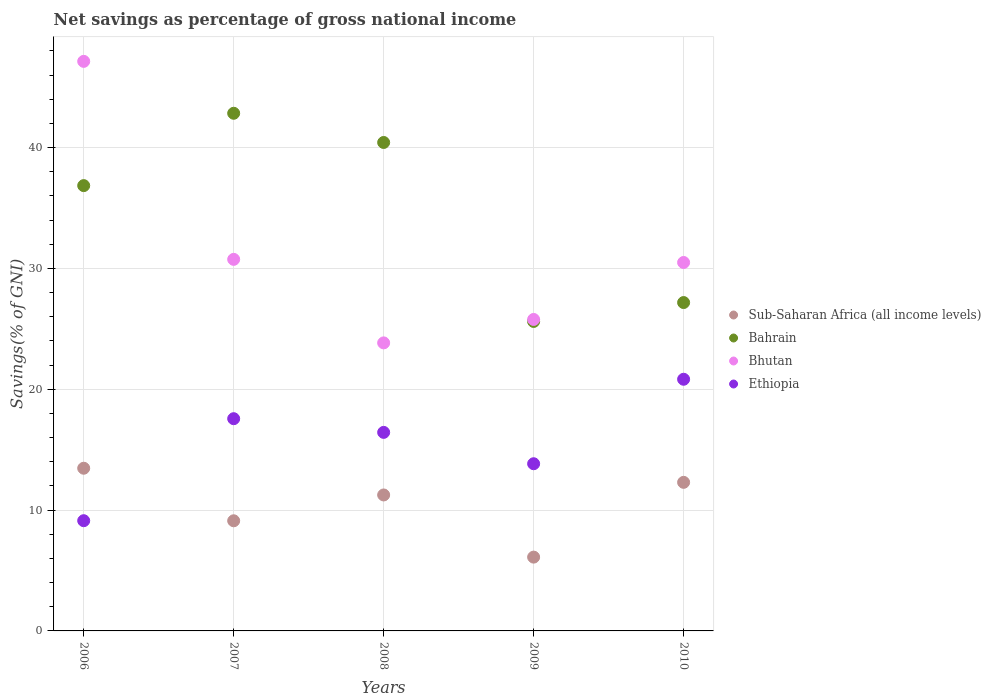How many different coloured dotlines are there?
Offer a terse response. 4. What is the total savings in Ethiopia in 2010?
Ensure brevity in your answer.  20.83. Across all years, what is the maximum total savings in Ethiopia?
Offer a terse response. 20.83. Across all years, what is the minimum total savings in Sub-Saharan Africa (all income levels)?
Give a very brief answer. 6.11. In which year was the total savings in Ethiopia maximum?
Keep it short and to the point. 2010. What is the total total savings in Bhutan in the graph?
Your response must be concise. 157.98. What is the difference between the total savings in Bahrain in 2006 and that in 2007?
Offer a very short reply. -5.99. What is the difference between the total savings in Bhutan in 2006 and the total savings in Ethiopia in 2008?
Keep it short and to the point. 30.7. What is the average total savings in Sub-Saharan Africa (all income levels) per year?
Give a very brief answer. 10.45. In the year 2008, what is the difference between the total savings in Bhutan and total savings in Ethiopia?
Your response must be concise. 7.41. In how many years, is the total savings in Ethiopia greater than 10 %?
Provide a succinct answer. 4. What is the ratio of the total savings in Sub-Saharan Africa (all income levels) in 2006 to that in 2008?
Give a very brief answer. 1.2. Is the total savings in Sub-Saharan Africa (all income levels) in 2009 less than that in 2010?
Provide a succinct answer. Yes. What is the difference between the highest and the second highest total savings in Bhutan?
Your answer should be compact. 16.39. What is the difference between the highest and the lowest total savings in Bhutan?
Your answer should be compact. 23.3. Is the sum of the total savings in Ethiopia in 2009 and 2010 greater than the maximum total savings in Sub-Saharan Africa (all income levels) across all years?
Offer a terse response. Yes. Is it the case that in every year, the sum of the total savings in Ethiopia and total savings in Bhutan  is greater than the sum of total savings in Sub-Saharan Africa (all income levels) and total savings in Bahrain?
Ensure brevity in your answer.  Yes. Is the total savings in Bhutan strictly less than the total savings in Bahrain over the years?
Keep it short and to the point. No. How many dotlines are there?
Provide a short and direct response. 4. How many years are there in the graph?
Offer a terse response. 5. What is the difference between two consecutive major ticks on the Y-axis?
Make the answer very short. 10. Are the values on the major ticks of Y-axis written in scientific E-notation?
Your answer should be very brief. No. What is the title of the graph?
Provide a succinct answer. Net savings as percentage of gross national income. What is the label or title of the X-axis?
Offer a terse response. Years. What is the label or title of the Y-axis?
Make the answer very short. Savings(% of GNI). What is the Savings(% of GNI) of Sub-Saharan Africa (all income levels) in 2006?
Your answer should be very brief. 13.46. What is the Savings(% of GNI) of Bahrain in 2006?
Your answer should be compact. 36.85. What is the Savings(% of GNI) in Bhutan in 2006?
Offer a very short reply. 47.13. What is the Savings(% of GNI) in Ethiopia in 2006?
Give a very brief answer. 9.12. What is the Savings(% of GNI) of Sub-Saharan Africa (all income levels) in 2007?
Ensure brevity in your answer.  9.11. What is the Savings(% of GNI) of Bahrain in 2007?
Your answer should be very brief. 42.84. What is the Savings(% of GNI) in Bhutan in 2007?
Ensure brevity in your answer.  30.75. What is the Savings(% of GNI) in Ethiopia in 2007?
Provide a succinct answer. 17.56. What is the Savings(% of GNI) in Sub-Saharan Africa (all income levels) in 2008?
Offer a very short reply. 11.25. What is the Savings(% of GNI) in Bahrain in 2008?
Keep it short and to the point. 40.42. What is the Savings(% of GNI) of Bhutan in 2008?
Provide a short and direct response. 23.84. What is the Savings(% of GNI) of Ethiopia in 2008?
Offer a very short reply. 16.43. What is the Savings(% of GNI) of Sub-Saharan Africa (all income levels) in 2009?
Your response must be concise. 6.11. What is the Savings(% of GNI) in Bahrain in 2009?
Your response must be concise. 25.61. What is the Savings(% of GNI) of Bhutan in 2009?
Provide a succinct answer. 25.78. What is the Savings(% of GNI) in Ethiopia in 2009?
Provide a succinct answer. 13.84. What is the Savings(% of GNI) in Sub-Saharan Africa (all income levels) in 2010?
Your answer should be compact. 12.3. What is the Savings(% of GNI) in Bahrain in 2010?
Give a very brief answer. 27.17. What is the Savings(% of GNI) in Bhutan in 2010?
Provide a succinct answer. 30.49. What is the Savings(% of GNI) of Ethiopia in 2010?
Give a very brief answer. 20.83. Across all years, what is the maximum Savings(% of GNI) in Sub-Saharan Africa (all income levels)?
Provide a succinct answer. 13.46. Across all years, what is the maximum Savings(% of GNI) of Bahrain?
Make the answer very short. 42.84. Across all years, what is the maximum Savings(% of GNI) in Bhutan?
Give a very brief answer. 47.13. Across all years, what is the maximum Savings(% of GNI) in Ethiopia?
Make the answer very short. 20.83. Across all years, what is the minimum Savings(% of GNI) of Sub-Saharan Africa (all income levels)?
Offer a very short reply. 6.11. Across all years, what is the minimum Savings(% of GNI) of Bahrain?
Your answer should be compact. 25.61. Across all years, what is the minimum Savings(% of GNI) of Bhutan?
Your response must be concise. 23.84. Across all years, what is the minimum Savings(% of GNI) in Ethiopia?
Your answer should be compact. 9.12. What is the total Savings(% of GNI) of Sub-Saharan Africa (all income levels) in the graph?
Keep it short and to the point. 52.23. What is the total Savings(% of GNI) in Bahrain in the graph?
Make the answer very short. 172.89. What is the total Savings(% of GNI) of Bhutan in the graph?
Give a very brief answer. 157.98. What is the total Savings(% of GNI) of Ethiopia in the graph?
Offer a terse response. 77.78. What is the difference between the Savings(% of GNI) of Sub-Saharan Africa (all income levels) in 2006 and that in 2007?
Your answer should be compact. 4.35. What is the difference between the Savings(% of GNI) of Bahrain in 2006 and that in 2007?
Your answer should be compact. -5.99. What is the difference between the Savings(% of GNI) in Bhutan in 2006 and that in 2007?
Your response must be concise. 16.39. What is the difference between the Savings(% of GNI) in Ethiopia in 2006 and that in 2007?
Give a very brief answer. -8.44. What is the difference between the Savings(% of GNI) in Sub-Saharan Africa (all income levels) in 2006 and that in 2008?
Your answer should be compact. 2.21. What is the difference between the Savings(% of GNI) of Bahrain in 2006 and that in 2008?
Your response must be concise. -3.57. What is the difference between the Savings(% of GNI) of Bhutan in 2006 and that in 2008?
Keep it short and to the point. 23.3. What is the difference between the Savings(% of GNI) of Ethiopia in 2006 and that in 2008?
Your answer should be very brief. -7.31. What is the difference between the Savings(% of GNI) in Sub-Saharan Africa (all income levels) in 2006 and that in 2009?
Your answer should be very brief. 7.36. What is the difference between the Savings(% of GNI) of Bahrain in 2006 and that in 2009?
Make the answer very short. 11.24. What is the difference between the Savings(% of GNI) of Bhutan in 2006 and that in 2009?
Offer a very short reply. 21.36. What is the difference between the Savings(% of GNI) of Ethiopia in 2006 and that in 2009?
Ensure brevity in your answer.  -4.71. What is the difference between the Savings(% of GNI) in Sub-Saharan Africa (all income levels) in 2006 and that in 2010?
Your answer should be compact. 1.17. What is the difference between the Savings(% of GNI) of Bahrain in 2006 and that in 2010?
Make the answer very short. 9.68. What is the difference between the Savings(% of GNI) in Bhutan in 2006 and that in 2010?
Your response must be concise. 16.64. What is the difference between the Savings(% of GNI) of Ethiopia in 2006 and that in 2010?
Ensure brevity in your answer.  -11.7. What is the difference between the Savings(% of GNI) in Sub-Saharan Africa (all income levels) in 2007 and that in 2008?
Your answer should be very brief. -2.14. What is the difference between the Savings(% of GNI) of Bahrain in 2007 and that in 2008?
Provide a succinct answer. 2.42. What is the difference between the Savings(% of GNI) in Bhutan in 2007 and that in 2008?
Give a very brief answer. 6.91. What is the difference between the Savings(% of GNI) of Ethiopia in 2007 and that in 2008?
Your response must be concise. 1.13. What is the difference between the Savings(% of GNI) in Sub-Saharan Africa (all income levels) in 2007 and that in 2009?
Your answer should be compact. 3.01. What is the difference between the Savings(% of GNI) of Bahrain in 2007 and that in 2009?
Give a very brief answer. 17.23. What is the difference between the Savings(% of GNI) in Bhutan in 2007 and that in 2009?
Your response must be concise. 4.97. What is the difference between the Savings(% of GNI) in Ethiopia in 2007 and that in 2009?
Keep it short and to the point. 3.73. What is the difference between the Savings(% of GNI) in Sub-Saharan Africa (all income levels) in 2007 and that in 2010?
Offer a terse response. -3.18. What is the difference between the Savings(% of GNI) in Bahrain in 2007 and that in 2010?
Provide a succinct answer. 15.66. What is the difference between the Savings(% of GNI) of Bhutan in 2007 and that in 2010?
Give a very brief answer. 0.26. What is the difference between the Savings(% of GNI) of Ethiopia in 2007 and that in 2010?
Keep it short and to the point. -3.26. What is the difference between the Savings(% of GNI) in Sub-Saharan Africa (all income levels) in 2008 and that in 2009?
Offer a very short reply. 5.14. What is the difference between the Savings(% of GNI) of Bahrain in 2008 and that in 2009?
Your answer should be very brief. 14.81. What is the difference between the Savings(% of GNI) of Bhutan in 2008 and that in 2009?
Provide a short and direct response. -1.94. What is the difference between the Savings(% of GNI) of Ethiopia in 2008 and that in 2009?
Make the answer very short. 2.59. What is the difference between the Savings(% of GNI) of Sub-Saharan Africa (all income levels) in 2008 and that in 2010?
Give a very brief answer. -1.04. What is the difference between the Savings(% of GNI) of Bahrain in 2008 and that in 2010?
Offer a terse response. 13.25. What is the difference between the Savings(% of GNI) of Bhutan in 2008 and that in 2010?
Provide a short and direct response. -6.65. What is the difference between the Savings(% of GNI) of Ethiopia in 2008 and that in 2010?
Your response must be concise. -4.4. What is the difference between the Savings(% of GNI) in Sub-Saharan Africa (all income levels) in 2009 and that in 2010?
Make the answer very short. -6.19. What is the difference between the Savings(% of GNI) of Bahrain in 2009 and that in 2010?
Offer a terse response. -1.56. What is the difference between the Savings(% of GNI) of Bhutan in 2009 and that in 2010?
Keep it short and to the point. -4.71. What is the difference between the Savings(% of GNI) in Ethiopia in 2009 and that in 2010?
Offer a very short reply. -6.99. What is the difference between the Savings(% of GNI) of Sub-Saharan Africa (all income levels) in 2006 and the Savings(% of GNI) of Bahrain in 2007?
Make the answer very short. -29.37. What is the difference between the Savings(% of GNI) in Sub-Saharan Africa (all income levels) in 2006 and the Savings(% of GNI) in Bhutan in 2007?
Offer a very short reply. -17.29. What is the difference between the Savings(% of GNI) of Sub-Saharan Africa (all income levels) in 2006 and the Savings(% of GNI) of Ethiopia in 2007?
Your answer should be very brief. -4.1. What is the difference between the Savings(% of GNI) in Bahrain in 2006 and the Savings(% of GNI) in Bhutan in 2007?
Offer a terse response. 6.1. What is the difference between the Savings(% of GNI) of Bahrain in 2006 and the Savings(% of GNI) of Ethiopia in 2007?
Provide a succinct answer. 19.29. What is the difference between the Savings(% of GNI) of Bhutan in 2006 and the Savings(% of GNI) of Ethiopia in 2007?
Provide a short and direct response. 29.57. What is the difference between the Savings(% of GNI) in Sub-Saharan Africa (all income levels) in 2006 and the Savings(% of GNI) in Bahrain in 2008?
Offer a very short reply. -26.96. What is the difference between the Savings(% of GNI) in Sub-Saharan Africa (all income levels) in 2006 and the Savings(% of GNI) in Bhutan in 2008?
Provide a short and direct response. -10.37. What is the difference between the Savings(% of GNI) in Sub-Saharan Africa (all income levels) in 2006 and the Savings(% of GNI) in Ethiopia in 2008?
Provide a short and direct response. -2.97. What is the difference between the Savings(% of GNI) in Bahrain in 2006 and the Savings(% of GNI) in Bhutan in 2008?
Provide a short and direct response. 13.01. What is the difference between the Savings(% of GNI) in Bahrain in 2006 and the Savings(% of GNI) in Ethiopia in 2008?
Give a very brief answer. 20.42. What is the difference between the Savings(% of GNI) of Bhutan in 2006 and the Savings(% of GNI) of Ethiopia in 2008?
Give a very brief answer. 30.7. What is the difference between the Savings(% of GNI) in Sub-Saharan Africa (all income levels) in 2006 and the Savings(% of GNI) in Bahrain in 2009?
Give a very brief answer. -12.15. What is the difference between the Savings(% of GNI) in Sub-Saharan Africa (all income levels) in 2006 and the Savings(% of GNI) in Bhutan in 2009?
Offer a terse response. -12.31. What is the difference between the Savings(% of GNI) in Sub-Saharan Africa (all income levels) in 2006 and the Savings(% of GNI) in Ethiopia in 2009?
Your answer should be compact. -0.37. What is the difference between the Savings(% of GNI) in Bahrain in 2006 and the Savings(% of GNI) in Bhutan in 2009?
Your answer should be very brief. 11.07. What is the difference between the Savings(% of GNI) of Bahrain in 2006 and the Savings(% of GNI) of Ethiopia in 2009?
Keep it short and to the point. 23.01. What is the difference between the Savings(% of GNI) of Bhutan in 2006 and the Savings(% of GNI) of Ethiopia in 2009?
Your answer should be very brief. 33.3. What is the difference between the Savings(% of GNI) of Sub-Saharan Africa (all income levels) in 2006 and the Savings(% of GNI) of Bahrain in 2010?
Your response must be concise. -13.71. What is the difference between the Savings(% of GNI) of Sub-Saharan Africa (all income levels) in 2006 and the Savings(% of GNI) of Bhutan in 2010?
Ensure brevity in your answer.  -17.03. What is the difference between the Savings(% of GNI) in Sub-Saharan Africa (all income levels) in 2006 and the Savings(% of GNI) in Ethiopia in 2010?
Provide a succinct answer. -7.36. What is the difference between the Savings(% of GNI) of Bahrain in 2006 and the Savings(% of GNI) of Bhutan in 2010?
Your answer should be compact. 6.36. What is the difference between the Savings(% of GNI) of Bahrain in 2006 and the Savings(% of GNI) of Ethiopia in 2010?
Give a very brief answer. 16.02. What is the difference between the Savings(% of GNI) of Bhutan in 2006 and the Savings(% of GNI) of Ethiopia in 2010?
Offer a very short reply. 26.31. What is the difference between the Savings(% of GNI) in Sub-Saharan Africa (all income levels) in 2007 and the Savings(% of GNI) in Bahrain in 2008?
Your answer should be very brief. -31.31. What is the difference between the Savings(% of GNI) of Sub-Saharan Africa (all income levels) in 2007 and the Savings(% of GNI) of Bhutan in 2008?
Keep it short and to the point. -14.72. What is the difference between the Savings(% of GNI) in Sub-Saharan Africa (all income levels) in 2007 and the Savings(% of GNI) in Ethiopia in 2008?
Make the answer very short. -7.32. What is the difference between the Savings(% of GNI) of Bahrain in 2007 and the Savings(% of GNI) of Bhutan in 2008?
Your answer should be compact. 19. What is the difference between the Savings(% of GNI) of Bahrain in 2007 and the Savings(% of GNI) of Ethiopia in 2008?
Keep it short and to the point. 26.41. What is the difference between the Savings(% of GNI) in Bhutan in 2007 and the Savings(% of GNI) in Ethiopia in 2008?
Offer a terse response. 14.32. What is the difference between the Savings(% of GNI) in Sub-Saharan Africa (all income levels) in 2007 and the Savings(% of GNI) in Bahrain in 2009?
Provide a short and direct response. -16.5. What is the difference between the Savings(% of GNI) of Sub-Saharan Africa (all income levels) in 2007 and the Savings(% of GNI) of Bhutan in 2009?
Give a very brief answer. -16.66. What is the difference between the Savings(% of GNI) of Sub-Saharan Africa (all income levels) in 2007 and the Savings(% of GNI) of Ethiopia in 2009?
Your answer should be compact. -4.72. What is the difference between the Savings(% of GNI) of Bahrain in 2007 and the Savings(% of GNI) of Bhutan in 2009?
Give a very brief answer. 17.06. What is the difference between the Savings(% of GNI) in Bahrain in 2007 and the Savings(% of GNI) in Ethiopia in 2009?
Keep it short and to the point. 29. What is the difference between the Savings(% of GNI) of Bhutan in 2007 and the Savings(% of GNI) of Ethiopia in 2009?
Your answer should be compact. 16.91. What is the difference between the Savings(% of GNI) in Sub-Saharan Africa (all income levels) in 2007 and the Savings(% of GNI) in Bahrain in 2010?
Your response must be concise. -18.06. What is the difference between the Savings(% of GNI) of Sub-Saharan Africa (all income levels) in 2007 and the Savings(% of GNI) of Bhutan in 2010?
Your answer should be compact. -21.38. What is the difference between the Savings(% of GNI) of Sub-Saharan Africa (all income levels) in 2007 and the Savings(% of GNI) of Ethiopia in 2010?
Offer a terse response. -11.71. What is the difference between the Savings(% of GNI) in Bahrain in 2007 and the Savings(% of GNI) in Bhutan in 2010?
Offer a very short reply. 12.35. What is the difference between the Savings(% of GNI) in Bahrain in 2007 and the Savings(% of GNI) in Ethiopia in 2010?
Provide a succinct answer. 22.01. What is the difference between the Savings(% of GNI) of Bhutan in 2007 and the Savings(% of GNI) of Ethiopia in 2010?
Keep it short and to the point. 9.92. What is the difference between the Savings(% of GNI) in Sub-Saharan Africa (all income levels) in 2008 and the Savings(% of GNI) in Bahrain in 2009?
Give a very brief answer. -14.36. What is the difference between the Savings(% of GNI) in Sub-Saharan Africa (all income levels) in 2008 and the Savings(% of GNI) in Bhutan in 2009?
Your answer should be very brief. -14.52. What is the difference between the Savings(% of GNI) in Sub-Saharan Africa (all income levels) in 2008 and the Savings(% of GNI) in Ethiopia in 2009?
Give a very brief answer. -2.58. What is the difference between the Savings(% of GNI) of Bahrain in 2008 and the Savings(% of GNI) of Bhutan in 2009?
Make the answer very short. 14.64. What is the difference between the Savings(% of GNI) in Bahrain in 2008 and the Savings(% of GNI) in Ethiopia in 2009?
Offer a terse response. 26.59. What is the difference between the Savings(% of GNI) of Bhutan in 2008 and the Savings(% of GNI) of Ethiopia in 2009?
Ensure brevity in your answer.  10. What is the difference between the Savings(% of GNI) in Sub-Saharan Africa (all income levels) in 2008 and the Savings(% of GNI) in Bahrain in 2010?
Ensure brevity in your answer.  -15.92. What is the difference between the Savings(% of GNI) of Sub-Saharan Africa (all income levels) in 2008 and the Savings(% of GNI) of Bhutan in 2010?
Your answer should be very brief. -19.24. What is the difference between the Savings(% of GNI) of Sub-Saharan Africa (all income levels) in 2008 and the Savings(% of GNI) of Ethiopia in 2010?
Make the answer very short. -9.57. What is the difference between the Savings(% of GNI) of Bahrain in 2008 and the Savings(% of GNI) of Bhutan in 2010?
Ensure brevity in your answer.  9.93. What is the difference between the Savings(% of GNI) of Bahrain in 2008 and the Savings(% of GNI) of Ethiopia in 2010?
Offer a terse response. 19.59. What is the difference between the Savings(% of GNI) of Bhutan in 2008 and the Savings(% of GNI) of Ethiopia in 2010?
Provide a short and direct response. 3.01. What is the difference between the Savings(% of GNI) of Sub-Saharan Africa (all income levels) in 2009 and the Savings(% of GNI) of Bahrain in 2010?
Offer a terse response. -21.07. What is the difference between the Savings(% of GNI) in Sub-Saharan Africa (all income levels) in 2009 and the Savings(% of GNI) in Bhutan in 2010?
Make the answer very short. -24.38. What is the difference between the Savings(% of GNI) of Sub-Saharan Africa (all income levels) in 2009 and the Savings(% of GNI) of Ethiopia in 2010?
Your answer should be very brief. -14.72. What is the difference between the Savings(% of GNI) of Bahrain in 2009 and the Savings(% of GNI) of Bhutan in 2010?
Provide a short and direct response. -4.88. What is the difference between the Savings(% of GNI) in Bahrain in 2009 and the Savings(% of GNI) in Ethiopia in 2010?
Ensure brevity in your answer.  4.78. What is the difference between the Savings(% of GNI) of Bhutan in 2009 and the Savings(% of GNI) of Ethiopia in 2010?
Ensure brevity in your answer.  4.95. What is the average Savings(% of GNI) of Sub-Saharan Africa (all income levels) per year?
Provide a succinct answer. 10.45. What is the average Savings(% of GNI) in Bahrain per year?
Provide a succinct answer. 34.58. What is the average Savings(% of GNI) in Bhutan per year?
Provide a succinct answer. 31.6. What is the average Savings(% of GNI) in Ethiopia per year?
Provide a succinct answer. 15.56. In the year 2006, what is the difference between the Savings(% of GNI) of Sub-Saharan Africa (all income levels) and Savings(% of GNI) of Bahrain?
Make the answer very short. -23.39. In the year 2006, what is the difference between the Savings(% of GNI) in Sub-Saharan Africa (all income levels) and Savings(% of GNI) in Bhutan?
Give a very brief answer. -33.67. In the year 2006, what is the difference between the Savings(% of GNI) of Sub-Saharan Africa (all income levels) and Savings(% of GNI) of Ethiopia?
Provide a succinct answer. 4.34. In the year 2006, what is the difference between the Savings(% of GNI) of Bahrain and Savings(% of GNI) of Bhutan?
Give a very brief answer. -10.28. In the year 2006, what is the difference between the Savings(% of GNI) in Bahrain and Savings(% of GNI) in Ethiopia?
Give a very brief answer. 27.73. In the year 2006, what is the difference between the Savings(% of GNI) in Bhutan and Savings(% of GNI) in Ethiopia?
Make the answer very short. 38.01. In the year 2007, what is the difference between the Savings(% of GNI) of Sub-Saharan Africa (all income levels) and Savings(% of GNI) of Bahrain?
Keep it short and to the point. -33.72. In the year 2007, what is the difference between the Savings(% of GNI) in Sub-Saharan Africa (all income levels) and Savings(% of GNI) in Bhutan?
Keep it short and to the point. -21.63. In the year 2007, what is the difference between the Savings(% of GNI) in Sub-Saharan Africa (all income levels) and Savings(% of GNI) in Ethiopia?
Your answer should be very brief. -8.45. In the year 2007, what is the difference between the Savings(% of GNI) in Bahrain and Savings(% of GNI) in Bhutan?
Make the answer very short. 12.09. In the year 2007, what is the difference between the Savings(% of GNI) of Bahrain and Savings(% of GNI) of Ethiopia?
Keep it short and to the point. 25.27. In the year 2007, what is the difference between the Savings(% of GNI) of Bhutan and Savings(% of GNI) of Ethiopia?
Provide a short and direct response. 13.19. In the year 2008, what is the difference between the Savings(% of GNI) in Sub-Saharan Africa (all income levels) and Savings(% of GNI) in Bahrain?
Make the answer very short. -29.17. In the year 2008, what is the difference between the Savings(% of GNI) in Sub-Saharan Africa (all income levels) and Savings(% of GNI) in Bhutan?
Offer a terse response. -12.58. In the year 2008, what is the difference between the Savings(% of GNI) in Sub-Saharan Africa (all income levels) and Savings(% of GNI) in Ethiopia?
Your response must be concise. -5.18. In the year 2008, what is the difference between the Savings(% of GNI) in Bahrain and Savings(% of GNI) in Bhutan?
Offer a terse response. 16.58. In the year 2008, what is the difference between the Savings(% of GNI) of Bahrain and Savings(% of GNI) of Ethiopia?
Your answer should be very brief. 23.99. In the year 2008, what is the difference between the Savings(% of GNI) of Bhutan and Savings(% of GNI) of Ethiopia?
Provide a succinct answer. 7.41. In the year 2009, what is the difference between the Savings(% of GNI) of Sub-Saharan Africa (all income levels) and Savings(% of GNI) of Bahrain?
Ensure brevity in your answer.  -19.5. In the year 2009, what is the difference between the Savings(% of GNI) of Sub-Saharan Africa (all income levels) and Savings(% of GNI) of Bhutan?
Give a very brief answer. -19.67. In the year 2009, what is the difference between the Savings(% of GNI) in Sub-Saharan Africa (all income levels) and Savings(% of GNI) in Ethiopia?
Keep it short and to the point. -7.73. In the year 2009, what is the difference between the Savings(% of GNI) of Bahrain and Savings(% of GNI) of Bhutan?
Your answer should be compact. -0.17. In the year 2009, what is the difference between the Savings(% of GNI) in Bahrain and Savings(% of GNI) in Ethiopia?
Offer a terse response. 11.77. In the year 2009, what is the difference between the Savings(% of GNI) in Bhutan and Savings(% of GNI) in Ethiopia?
Your answer should be compact. 11.94. In the year 2010, what is the difference between the Savings(% of GNI) in Sub-Saharan Africa (all income levels) and Savings(% of GNI) in Bahrain?
Provide a succinct answer. -14.88. In the year 2010, what is the difference between the Savings(% of GNI) in Sub-Saharan Africa (all income levels) and Savings(% of GNI) in Bhutan?
Your response must be concise. -18.19. In the year 2010, what is the difference between the Savings(% of GNI) of Sub-Saharan Africa (all income levels) and Savings(% of GNI) of Ethiopia?
Provide a succinct answer. -8.53. In the year 2010, what is the difference between the Savings(% of GNI) in Bahrain and Savings(% of GNI) in Bhutan?
Your answer should be compact. -3.32. In the year 2010, what is the difference between the Savings(% of GNI) of Bahrain and Savings(% of GNI) of Ethiopia?
Your response must be concise. 6.35. In the year 2010, what is the difference between the Savings(% of GNI) of Bhutan and Savings(% of GNI) of Ethiopia?
Give a very brief answer. 9.66. What is the ratio of the Savings(% of GNI) in Sub-Saharan Africa (all income levels) in 2006 to that in 2007?
Your response must be concise. 1.48. What is the ratio of the Savings(% of GNI) in Bahrain in 2006 to that in 2007?
Offer a very short reply. 0.86. What is the ratio of the Savings(% of GNI) in Bhutan in 2006 to that in 2007?
Keep it short and to the point. 1.53. What is the ratio of the Savings(% of GNI) of Ethiopia in 2006 to that in 2007?
Offer a terse response. 0.52. What is the ratio of the Savings(% of GNI) of Sub-Saharan Africa (all income levels) in 2006 to that in 2008?
Your response must be concise. 1.2. What is the ratio of the Savings(% of GNI) of Bahrain in 2006 to that in 2008?
Provide a short and direct response. 0.91. What is the ratio of the Savings(% of GNI) of Bhutan in 2006 to that in 2008?
Your response must be concise. 1.98. What is the ratio of the Savings(% of GNI) in Ethiopia in 2006 to that in 2008?
Your answer should be very brief. 0.56. What is the ratio of the Savings(% of GNI) in Sub-Saharan Africa (all income levels) in 2006 to that in 2009?
Make the answer very short. 2.2. What is the ratio of the Savings(% of GNI) of Bahrain in 2006 to that in 2009?
Your answer should be very brief. 1.44. What is the ratio of the Savings(% of GNI) of Bhutan in 2006 to that in 2009?
Give a very brief answer. 1.83. What is the ratio of the Savings(% of GNI) of Ethiopia in 2006 to that in 2009?
Your answer should be compact. 0.66. What is the ratio of the Savings(% of GNI) in Sub-Saharan Africa (all income levels) in 2006 to that in 2010?
Keep it short and to the point. 1.09. What is the ratio of the Savings(% of GNI) in Bahrain in 2006 to that in 2010?
Provide a succinct answer. 1.36. What is the ratio of the Savings(% of GNI) in Bhutan in 2006 to that in 2010?
Offer a very short reply. 1.55. What is the ratio of the Savings(% of GNI) in Ethiopia in 2006 to that in 2010?
Your answer should be very brief. 0.44. What is the ratio of the Savings(% of GNI) in Sub-Saharan Africa (all income levels) in 2007 to that in 2008?
Provide a short and direct response. 0.81. What is the ratio of the Savings(% of GNI) of Bahrain in 2007 to that in 2008?
Keep it short and to the point. 1.06. What is the ratio of the Savings(% of GNI) of Bhutan in 2007 to that in 2008?
Offer a terse response. 1.29. What is the ratio of the Savings(% of GNI) of Ethiopia in 2007 to that in 2008?
Offer a terse response. 1.07. What is the ratio of the Savings(% of GNI) in Sub-Saharan Africa (all income levels) in 2007 to that in 2009?
Your answer should be compact. 1.49. What is the ratio of the Savings(% of GNI) in Bahrain in 2007 to that in 2009?
Offer a terse response. 1.67. What is the ratio of the Savings(% of GNI) in Bhutan in 2007 to that in 2009?
Provide a short and direct response. 1.19. What is the ratio of the Savings(% of GNI) in Ethiopia in 2007 to that in 2009?
Provide a short and direct response. 1.27. What is the ratio of the Savings(% of GNI) in Sub-Saharan Africa (all income levels) in 2007 to that in 2010?
Ensure brevity in your answer.  0.74. What is the ratio of the Savings(% of GNI) of Bahrain in 2007 to that in 2010?
Your answer should be very brief. 1.58. What is the ratio of the Savings(% of GNI) of Bhutan in 2007 to that in 2010?
Your answer should be very brief. 1.01. What is the ratio of the Savings(% of GNI) of Ethiopia in 2007 to that in 2010?
Provide a short and direct response. 0.84. What is the ratio of the Savings(% of GNI) in Sub-Saharan Africa (all income levels) in 2008 to that in 2009?
Ensure brevity in your answer.  1.84. What is the ratio of the Savings(% of GNI) of Bahrain in 2008 to that in 2009?
Provide a succinct answer. 1.58. What is the ratio of the Savings(% of GNI) of Bhutan in 2008 to that in 2009?
Offer a very short reply. 0.92. What is the ratio of the Savings(% of GNI) of Ethiopia in 2008 to that in 2009?
Offer a very short reply. 1.19. What is the ratio of the Savings(% of GNI) of Sub-Saharan Africa (all income levels) in 2008 to that in 2010?
Keep it short and to the point. 0.92. What is the ratio of the Savings(% of GNI) of Bahrain in 2008 to that in 2010?
Your response must be concise. 1.49. What is the ratio of the Savings(% of GNI) in Bhutan in 2008 to that in 2010?
Ensure brevity in your answer.  0.78. What is the ratio of the Savings(% of GNI) in Ethiopia in 2008 to that in 2010?
Make the answer very short. 0.79. What is the ratio of the Savings(% of GNI) of Sub-Saharan Africa (all income levels) in 2009 to that in 2010?
Offer a very short reply. 0.5. What is the ratio of the Savings(% of GNI) of Bahrain in 2009 to that in 2010?
Offer a very short reply. 0.94. What is the ratio of the Savings(% of GNI) in Bhutan in 2009 to that in 2010?
Your answer should be very brief. 0.85. What is the ratio of the Savings(% of GNI) in Ethiopia in 2009 to that in 2010?
Keep it short and to the point. 0.66. What is the difference between the highest and the second highest Savings(% of GNI) in Sub-Saharan Africa (all income levels)?
Your answer should be very brief. 1.17. What is the difference between the highest and the second highest Savings(% of GNI) of Bahrain?
Your response must be concise. 2.42. What is the difference between the highest and the second highest Savings(% of GNI) in Bhutan?
Your answer should be very brief. 16.39. What is the difference between the highest and the second highest Savings(% of GNI) of Ethiopia?
Provide a succinct answer. 3.26. What is the difference between the highest and the lowest Savings(% of GNI) in Sub-Saharan Africa (all income levels)?
Your response must be concise. 7.36. What is the difference between the highest and the lowest Savings(% of GNI) of Bahrain?
Provide a succinct answer. 17.23. What is the difference between the highest and the lowest Savings(% of GNI) of Bhutan?
Your answer should be very brief. 23.3. What is the difference between the highest and the lowest Savings(% of GNI) of Ethiopia?
Offer a terse response. 11.7. 